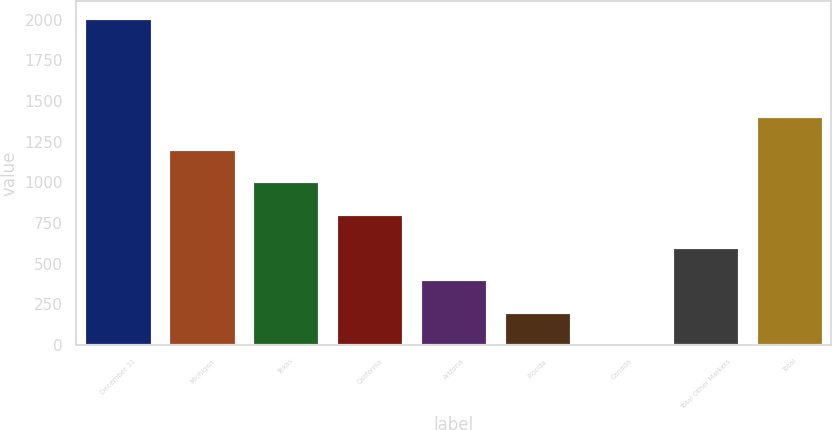Convert chart to OTSL. <chart><loc_0><loc_0><loc_500><loc_500><bar_chart><fcel>December 31<fcel>Michigan<fcel>Texas<fcel>California<fcel>Arizona<fcel>Florida<fcel>Canada<fcel>Total Other Markets<fcel>Total<nl><fcel>2012<fcel>1207.6<fcel>1006.5<fcel>805.4<fcel>403.2<fcel>202.1<fcel>1<fcel>604.3<fcel>1408.7<nl></chart> 